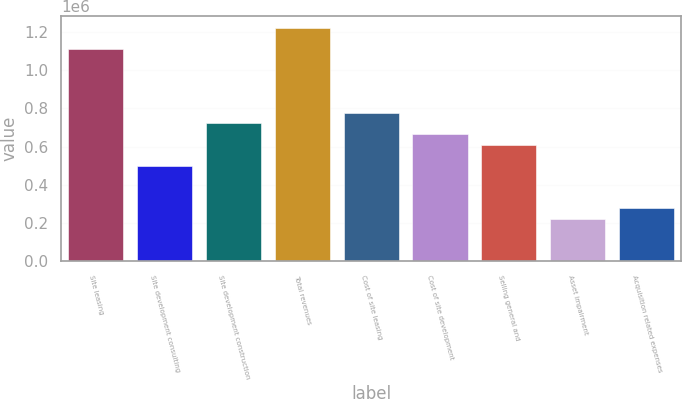<chart> <loc_0><loc_0><loc_500><loc_500><bar_chart><fcel>Site leasing<fcel>Site development consulting<fcel>Site development construction<fcel>Total revenues<fcel>Cost of site leasing<fcel>Cost of site development<fcel>Selling general and<fcel>Asset impairment<fcel>Acquisition related expenses<nl><fcel>1.11086e+06<fcel>499978<fcel>722118<fcel>1.22193e+06<fcel>777653<fcel>666583<fcel>611048<fcel>222303<fcel>277838<nl></chart> 